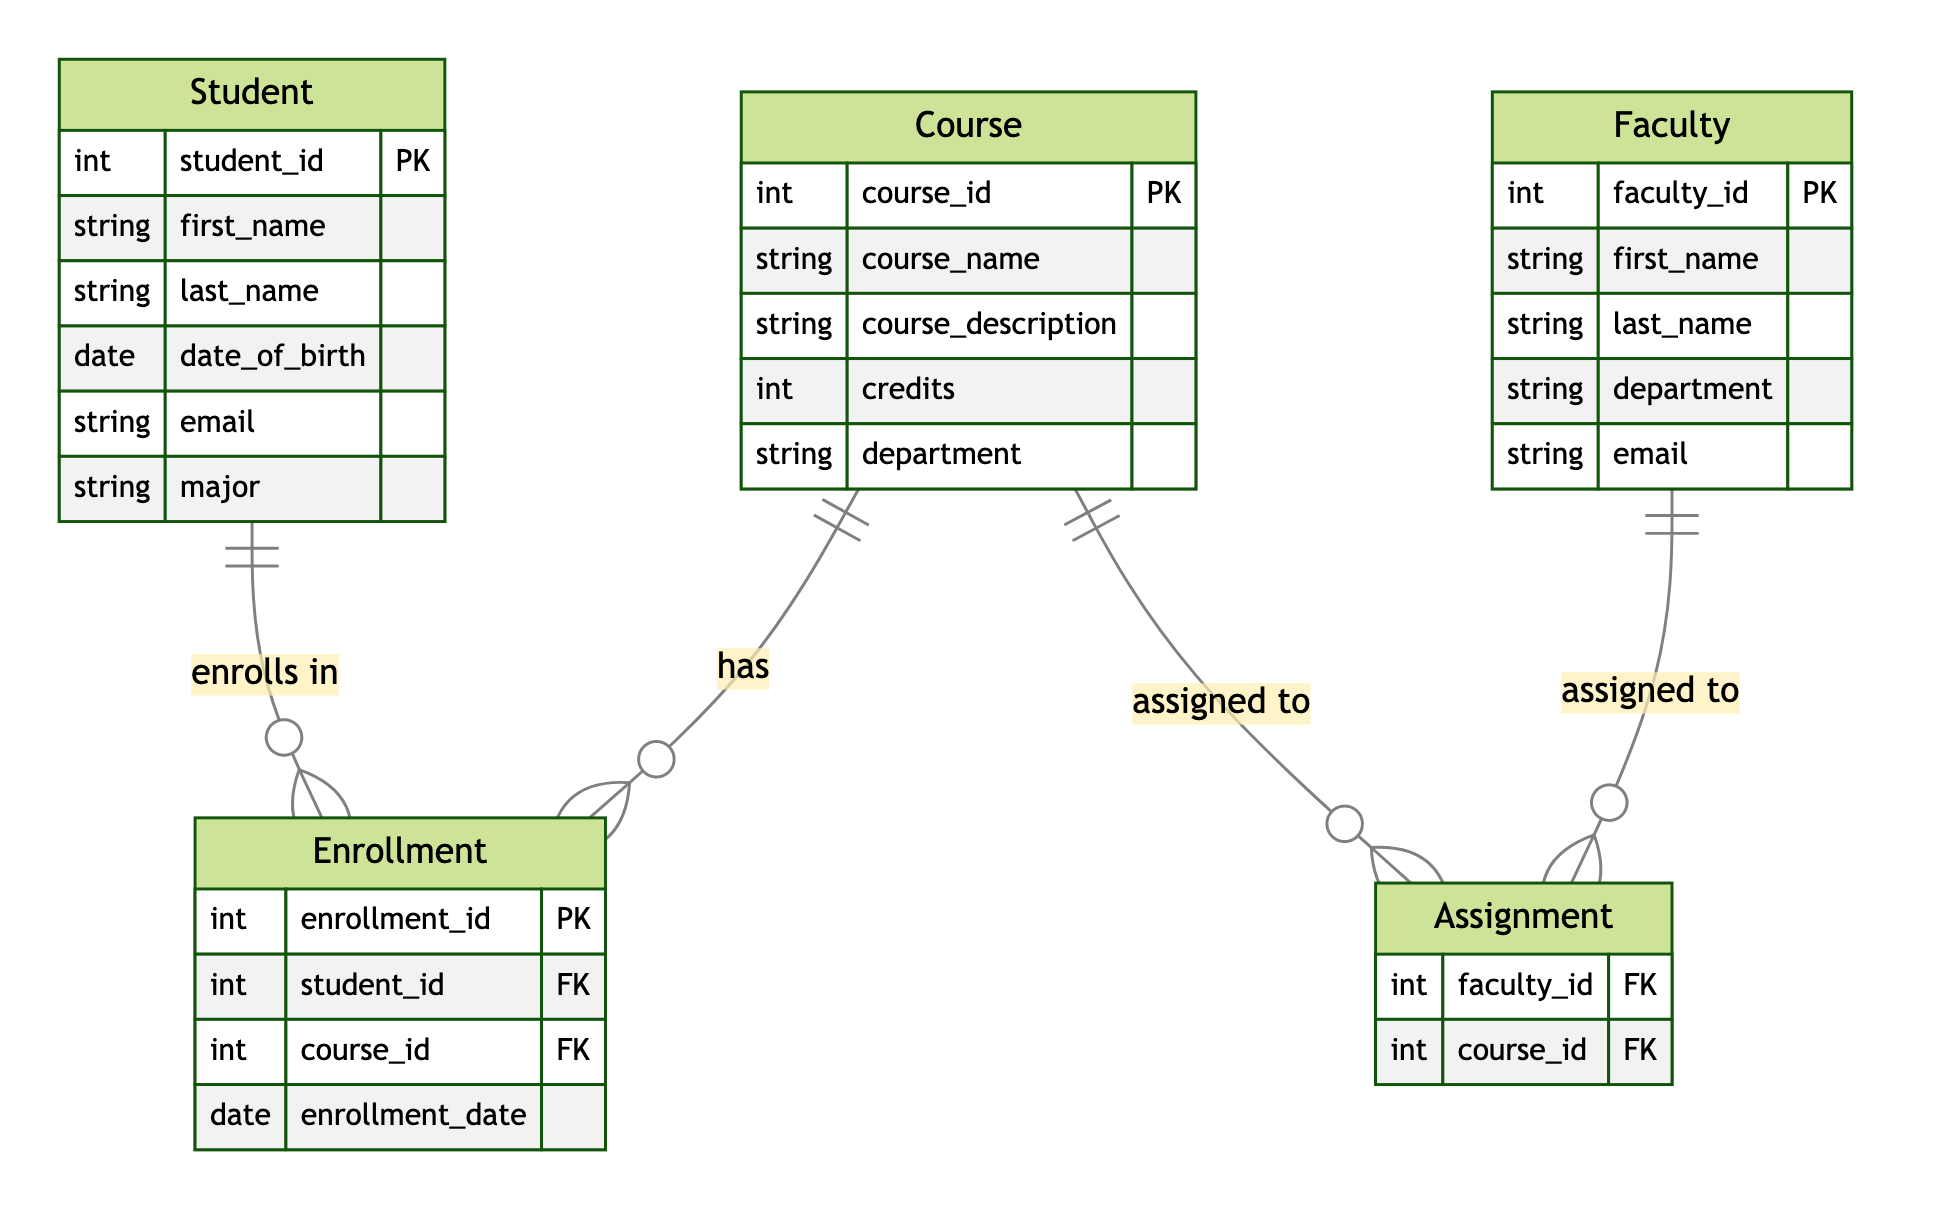What is the primary key of the Student entity? The primary key for the Student entity is defined as "student_id", which uniquely identifies each student in the system.
Answer: student_id How many attributes are there in the Course entity? The Course entity has five attributes: course_id, course_name, course_description, credits, and department.
Answer: 5 What type of relationship exists between Student and Enrollment? The diagram indicates a one-to-many relationship between Student and Enrollment, meaning one student can enroll in multiple courses.
Answer: One-to-Many What is the foreign key in the Assignment entity? The Assignment entity contains two foreign keys: faculty_id and course_id, which link assignments to both faculty and courses.
Answer: faculty_id, course_id How many entities are present in the diagram? The diagram includes five entities: Student, Course, Faculty, Enrollment, and Assignment.
Answer: 5 Which relationship links a Faculty member to a Course? The diagram shows that the relationship linking a Faculty member to a Course is called "assigned to", indicating that faculty can be assigned to multiple courses.
Answer: assigned to What is the maximum number of Enrollment entries a single Course can have? Given the one-to-many relationship between Course and Enrollment, a single Course can have multiple Enrollment entries, but the exact number is not defined in the diagram.
Answer: Many Which entity includes the date of birth attribute? The attribute "date_of_birth" is present in the Student entity, which holds the birth date of each student.
Answer: Student What does the Enrollment entity represent in the context of the system? The Enrollment entity represents the records of students enrolling in various courses, including the student ID, course ID, and the date of enrollment.
Answer: Enrollment records 